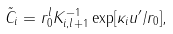Convert formula to latex. <formula><loc_0><loc_0><loc_500><loc_500>\tilde { C } _ { i } = r _ { 0 } ^ { l } K ^ { - 1 } _ { i , l + 1 } \exp [ \kappa _ { i } u ^ { \prime } / r _ { 0 } ] ,</formula> 